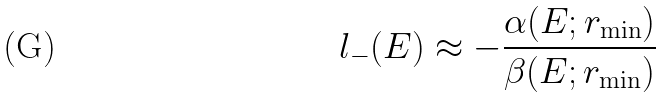<formula> <loc_0><loc_0><loc_500><loc_500>l _ { - } ( E ) \approx - \frac { \alpha ( E ; r _ { \min } ) } { \beta ( E ; r _ { \min } ) }</formula> 